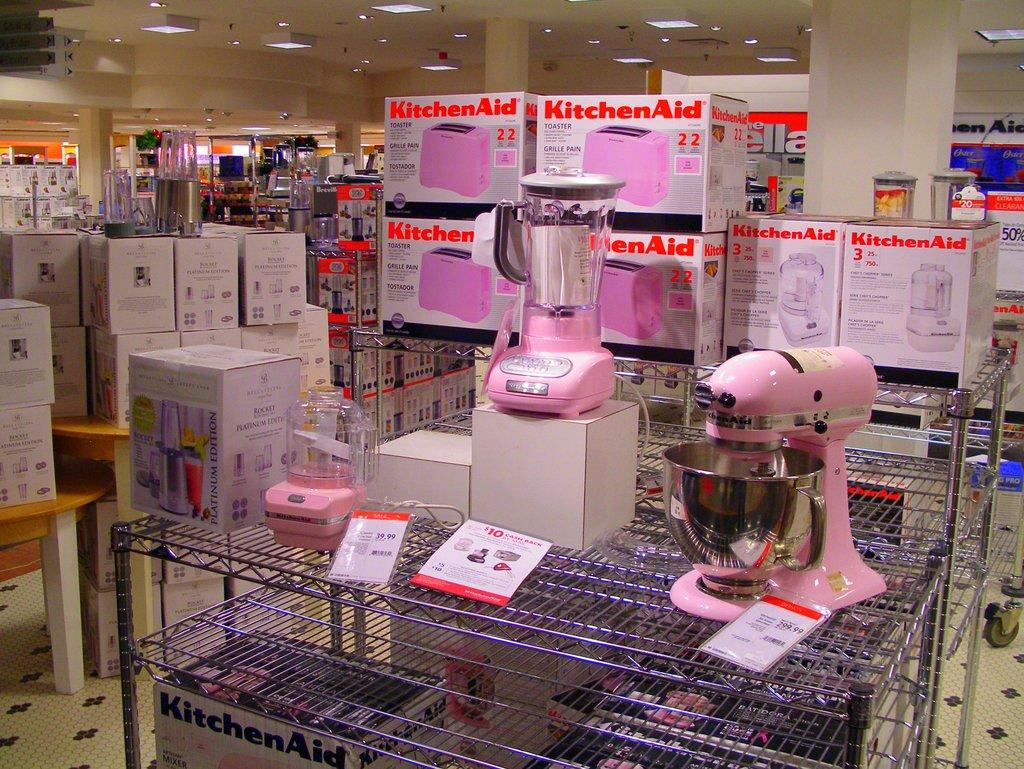<image>
Summarize the visual content of the image. A stand of kitchen aid appliances including toasters and mixers are all pink and displayed in a store. 